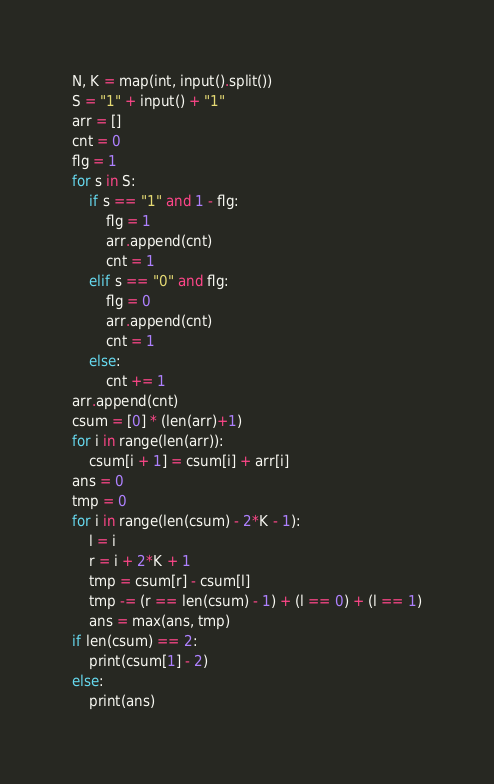<code> <loc_0><loc_0><loc_500><loc_500><_Python_>N, K = map(int, input().split())
S = "1" + input() + "1"
arr = []
cnt = 0
flg = 1
for s in S:
    if s == "1" and 1 - flg:
        flg = 1
        arr.append(cnt)
        cnt = 1
    elif s == "0" and flg:
        flg = 0
        arr.append(cnt)
        cnt = 1
    else:
        cnt += 1
arr.append(cnt)
csum = [0] * (len(arr)+1)
for i in range(len(arr)):
    csum[i + 1] = csum[i] + arr[i]
ans = 0
tmp = 0
for i in range(len(csum) - 2*K - 1):
    l = i
    r = i + 2*K + 1
    tmp = csum[r] - csum[l]
    tmp -= (r == len(csum) - 1) + (l == 0) + (l == 1)
    ans = max(ans, tmp)
if len(csum) == 2:
    print(csum[1] - 2)
else:
    print(ans)
</code> 